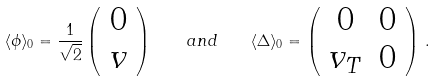Convert formula to latex. <formula><loc_0><loc_0><loc_500><loc_500>\langle \phi \rangle _ { 0 } = \frac { 1 } { \sqrt { 2 } } \left ( \begin{array} { c } 0 \\ v \end{array} \right ) \quad a n d \quad \langle \Delta \rangle _ { 0 } = \left ( \begin{array} { c c } 0 & 0 \\ v _ { T } & 0 \end{array} \right ) \, .</formula> 